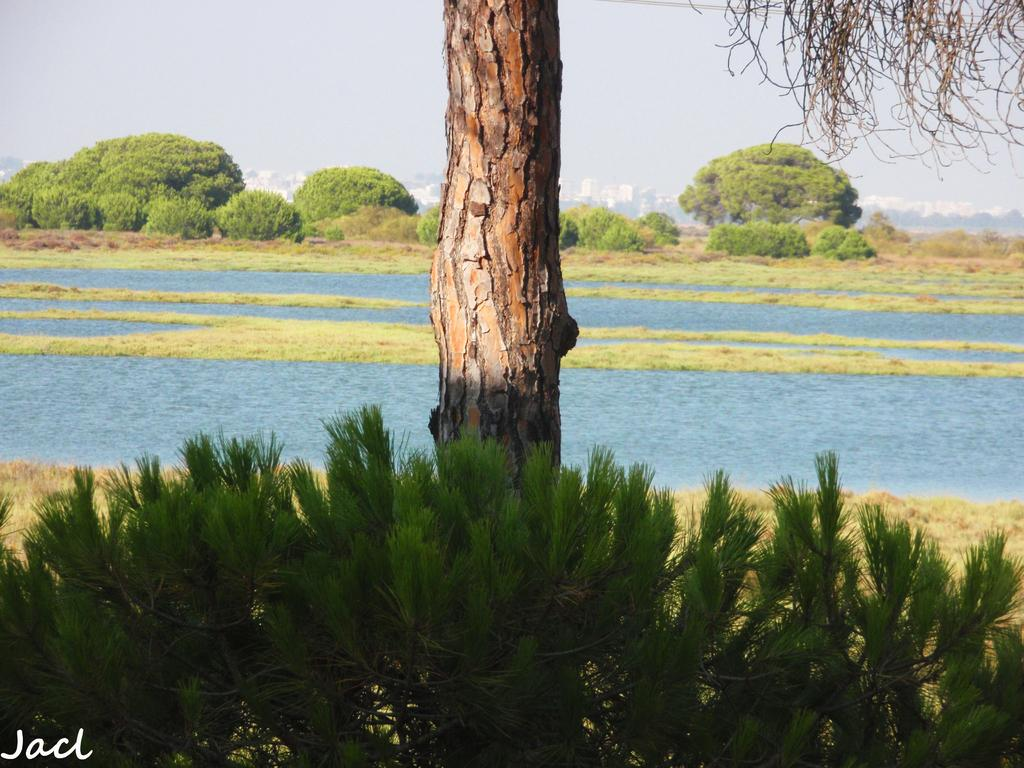What type of natural environment is depicted in the image? The image contains grass, water, and trees, which are elements of a natural environment. Can you describe the tree trunk in the image? The tree trunk is visible in the image. What is visible in the sky in the image? The sky is visible in the image. What type of man-made structures can be seen in the image? There are buildings in the image. Is there any text or marking on the image? Yes, there is a watermark on the bottom left of the image. What type of chess piece is located on the tree branch in the image? There is no chess piece present in the image, as it features natural elements like grass, water, and trees, and man-made structures like buildings. Can you hear the cough of the person in the image? There is no person present in the image, so it is not possible to hear any coughs. 